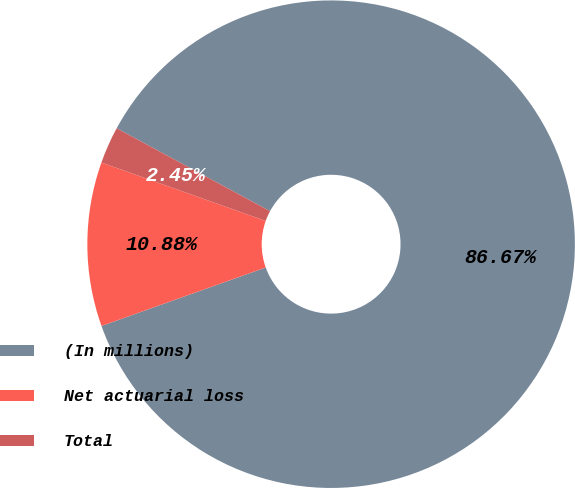Convert chart to OTSL. <chart><loc_0><loc_0><loc_500><loc_500><pie_chart><fcel>(In millions)<fcel>Net actuarial loss<fcel>Total<nl><fcel>86.67%<fcel>10.88%<fcel>2.45%<nl></chart> 